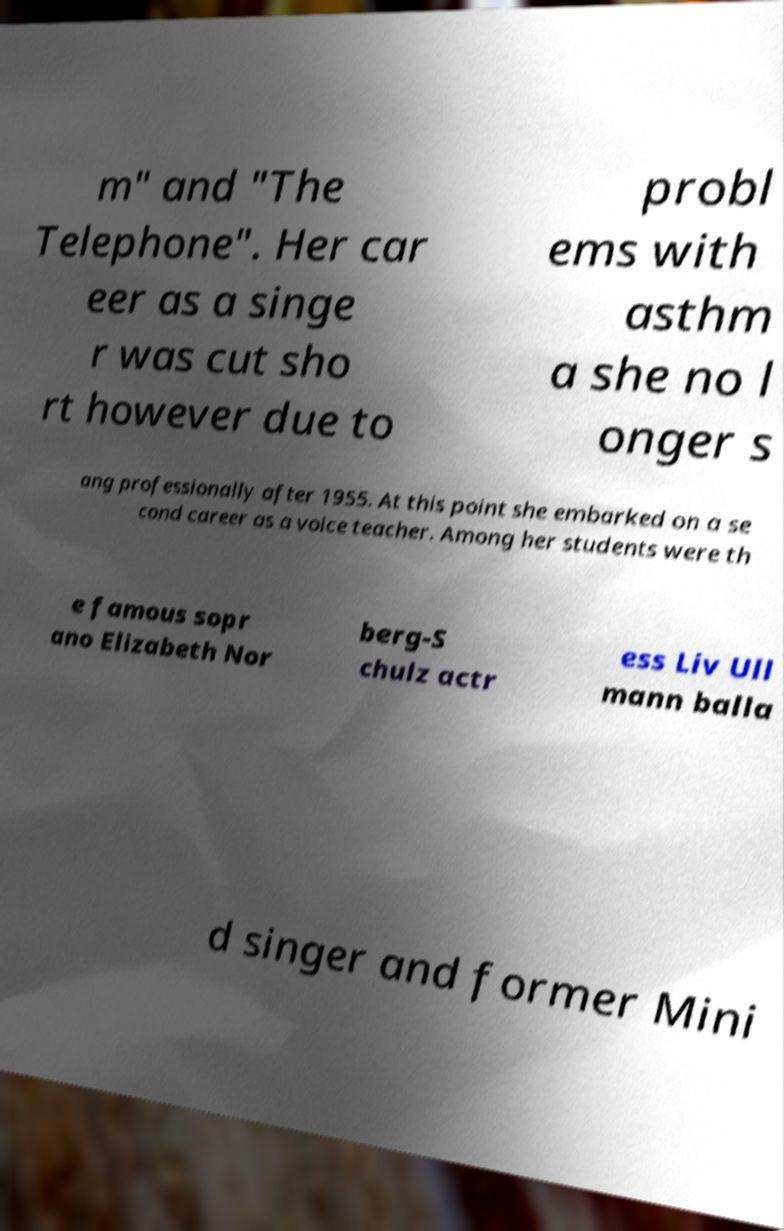For documentation purposes, I need the text within this image transcribed. Could you provide that? m" and "The Telephone". Her car eer as a singe r was cut sho rt however due to probl ems with asthm a she no l onger s ang professionally after 1955. At this point she embarked on a se cond career as a voice teacher. Among her students were th e famous sopr ano Elizabeth Nor berg-S chulz actr ess Liv Ull mann balla d singer and former Mini 